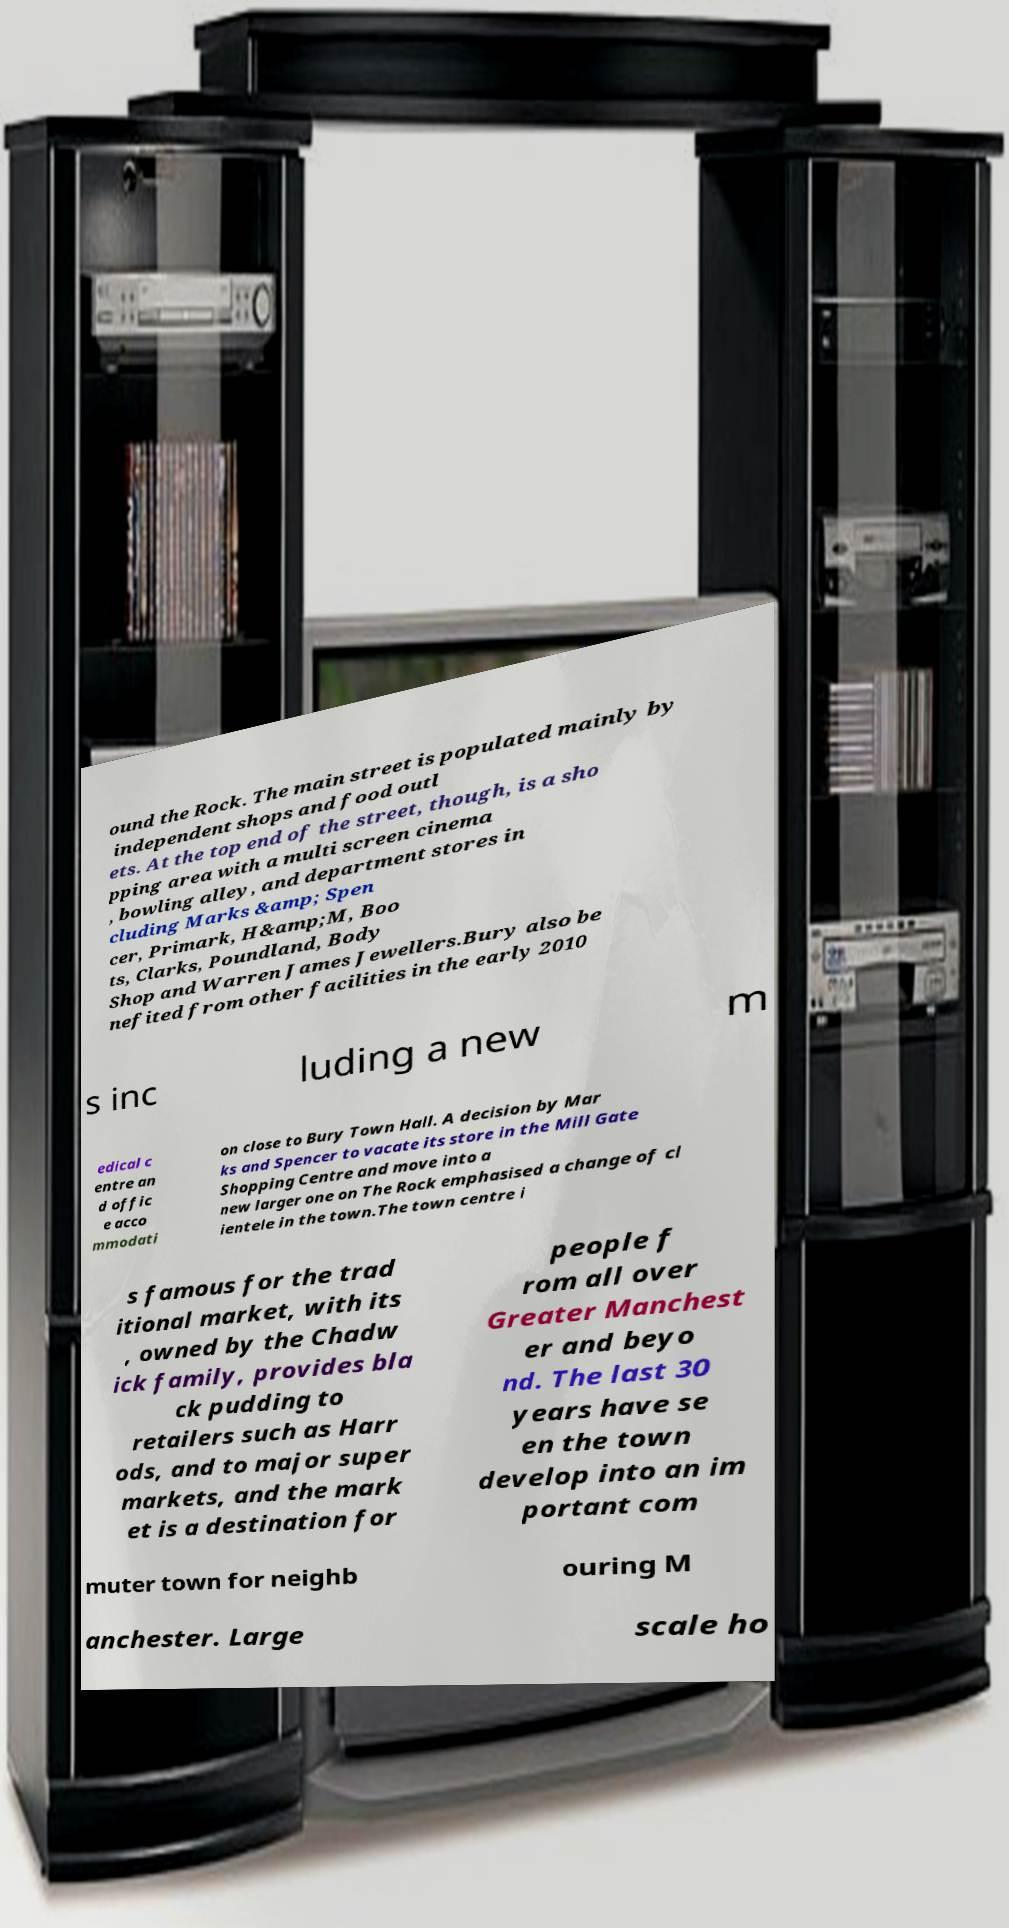Could you assist in decoding the text presented in this image and type it out clearly? ound the Rock. The main street is populated mainly by independent shops and food outl ets. At the top end of the street, though, is a sho pping area with a multi screen cinema , bowling alley, and department stores in cluding Marks &amp; Spen cer, Primark, H&amp;M, Boo ts, Clarks, Poundland, Body Shop and Warren James Jewellers.Bury also be nefited from other facilities in the early 2010 s inc luding a new m edical c entre an d offic e acco mmodati on close to Bury Town Hall. A decision by Mar ks and Spencer to vacate its store in the Mill Gate Shopping Centre and move into a new larger one on The Rock emphasised a change of cl ientele in the town.The town centre i s famous for the trad itional market, with its , owned by the Chadw ick family, provides bla ck pudding to retailers such as Harr ods, and to major super markets, and the mark et is a destination for people f rom all over Greater Manchest er and beyo nd. The last 30 years have se en the town develop into an im portant com muter town for neighb ouring M anchester. Large scale ho 